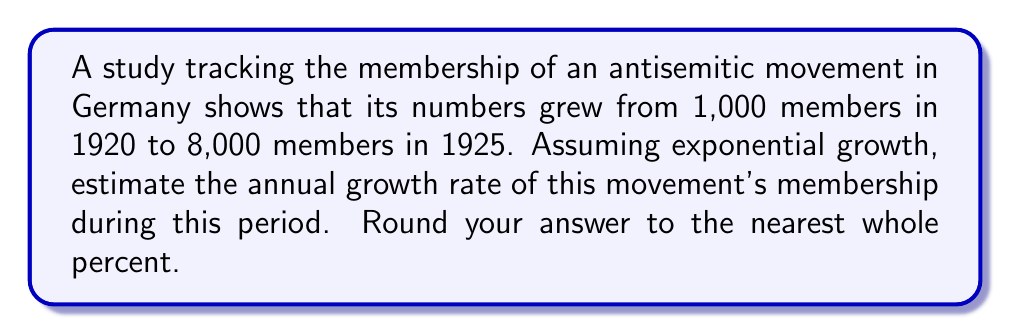Can you answer this question? To solve this problem, we'll use the exponential growth formula:

$$A = P(1 + r)^t$$

Where:
$A$ = Final amount (8,000 members)
$P$ = Initial amount (1,000 members)
$r$ = Annual growth rate (what we're solving for)
$t$ = Time period (5 years)

Step 1: Plug the known values into the formula:
$$8000 = 1000(1 + r)^5$$

Step 2: Divide both sides by 1000:
$$8 = (1 + r)^5$$

Step 3: Take the 5th root of both sides:
$$\sqrt[5]{8} = 1 + r$$

Step 4: Calculate the 5th root of 8:
$$1.5157... = 1 + r$$

Step 5: Subtract 1 from both sides:
$$0.5157... = r$$

Step 6: Convert to a percentage by multiplying by 100:
$$51.57\% \approx 52\%$$

Rounding to the nearest whole percent gives us 52%.
Answer: 52% 